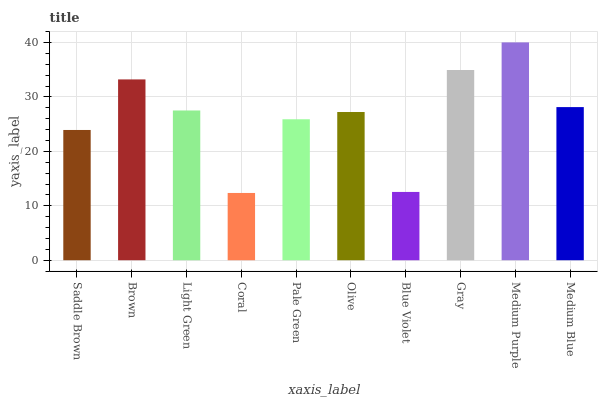Is Coral the minimum?
Answer yes or no. Yes. Is Medium Purple the maximum?
Answer yes or no. Yes. Is Brown the minimum?
Answer yes or no. No. Is Brown the maximum?
Answer yes or no. No. Is Brown greater than Saddle Brown?
Answer yes or no. Yes. Is Saddle Brown less than Brown?
Answer yes or no. Yes. Is Saddle Brown greater than Brown?
Answer yes or no. No. Is Brown less than Saddle Brown?
Answer yes or no. No. Is Light Green the high median?
Answer yes or no. Yes. Is Olive the low median?
Answer yes or no. Yes. Is Medium Blue the high median?
Answer yes or no. No. Is Pale Green the low median?
Answer yes or no. No. 